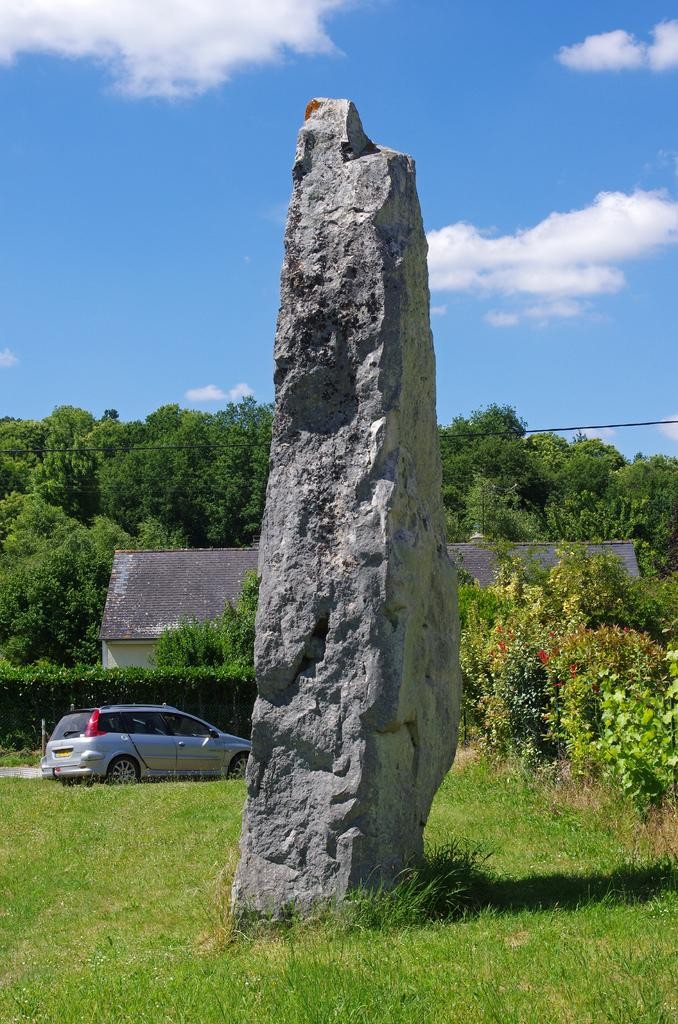What is the main subject in the center of the image? There is a rock in the center of the image. What structures or objects can be seen in the background of the image? There is a shed and a vehicle in the background of the image. What type of vegetation is visible in the background of the image? There are many trees in the background of the image. What is visible in the sky at the top of the image? There are clouds visible in the sky at the top of the image. What type of hammer is being used to walk on the clouds in the image? There is no hammer or walking on clouds present in the image; it features a rock, a shed, a vehicle, trees, and clouds in the sky. 